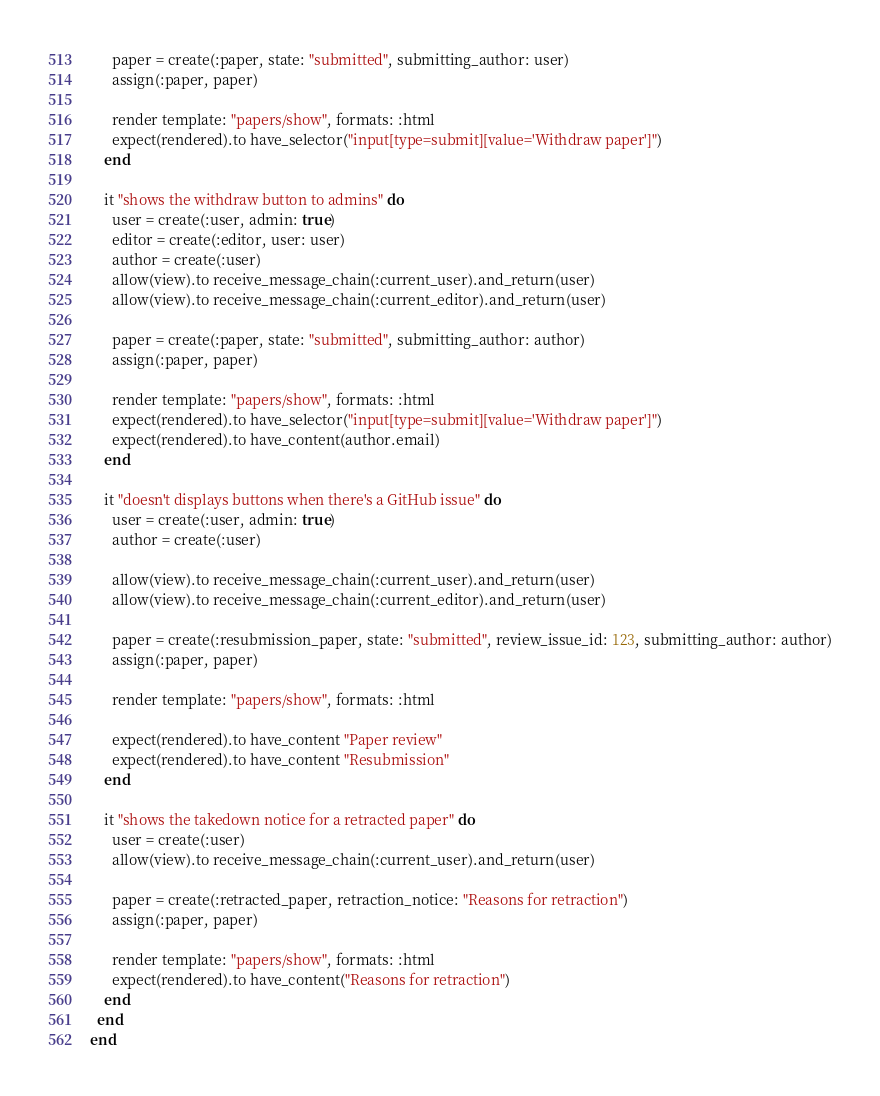<code> <loc_0><loc_0><loc_500><loc_500><_Ruby_>
      paper = create(:paper, state: "submitted", submitting_author: user)
      assign(:paper, paper)

      render template: "papers/show", formats: :html
      expect(rendered).to have_selector("input[type=submit][value='Withdraw paper']")
    end

    it "shows the withdraw button to admins" do
      user = create(:user, admin: true)
      editor = create(:editor, user: user)
      author = create(:user)
      allow(view).to receive_message_chain(:current_user).and_return(user)
      allow(view).to receive_message_chain(:current_editor).and_return(user)

      paper = create(:paper, state: "submitted", submitting_author: author)
      assign(:paper, paper)

      render template: "papers/show", formats: :html
      expect(rendered).to have_selector("input[type=submit][value='Withdraw paper']")
      expect(rendered).to have_content(author.email)
    end

    it "doesn't displays buttons when there's a GitHub issue" do
      user = create(:user, admin: true)
      author = create(:user)

      allow(view).to receive_message_chain(:current_user).and_return(user)
      allow(view).to receive_message_chain(:current_editor).and_return(user)

      paper = create(:resubmission_paper, state: "submitted", review_issue_id: 123, submitting_author: author)
      assign(:paper, paper)

      render template: "papers/show", formats: :html

      expect(rendered).to have_content "Paper review"
      expect(rendered).to have_content "Resubmission"
    end

    it "shows the takedown notice for a retracted paper" do
      user = create(:user)
      allow(view).to receive_message_chain(:current_user).and_return(user)

      paper = create(:retracted_paper, retraction_notice: "Reasons for retraction")
      assign(:paper, paper)

      render template: "papers/show", formats: :html
      expect(rendered).to have_content("Reasons for retraction")
    end
  end
end
</code> 